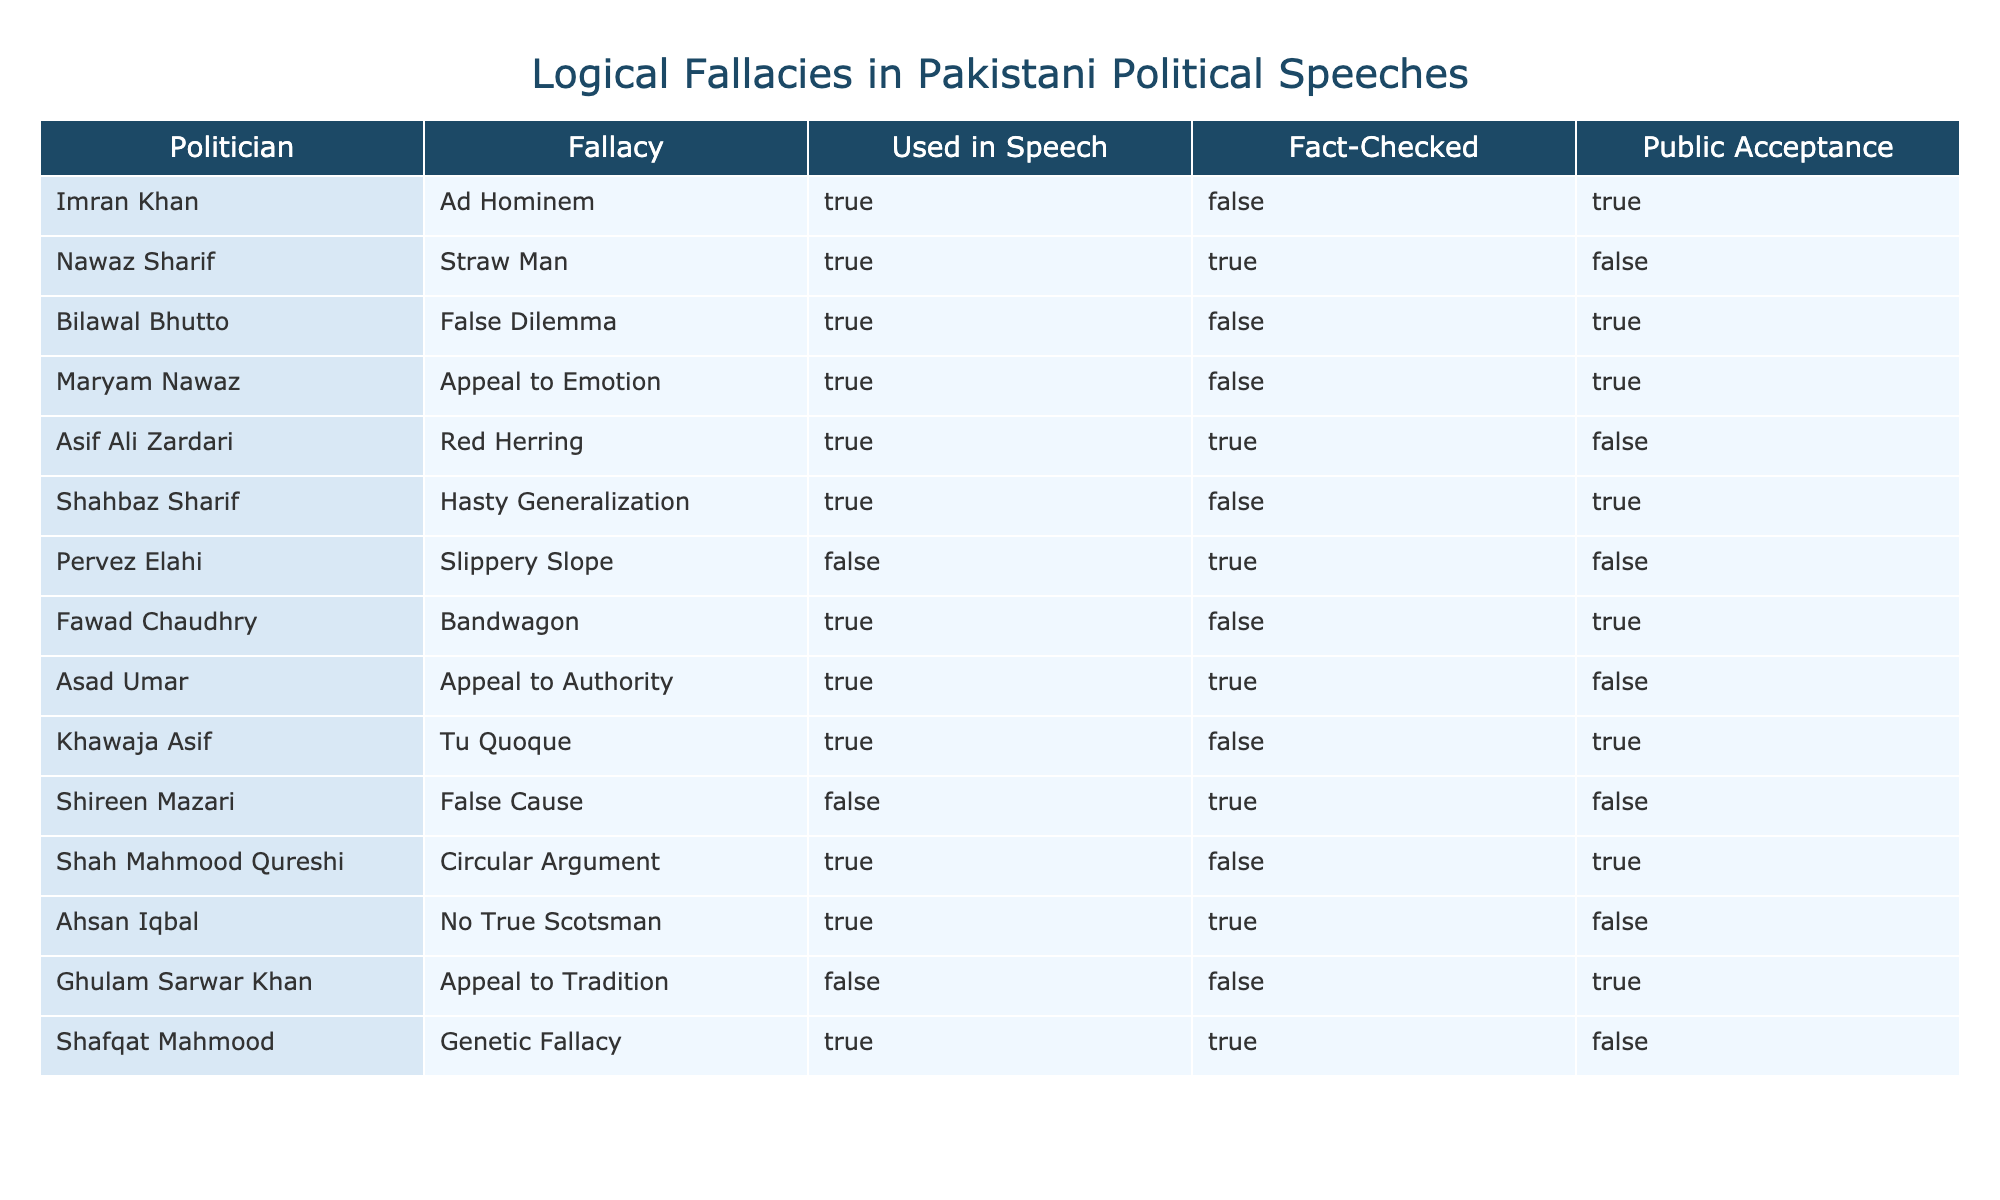What logical fallacy did Bilawal Bhutto use in his speech? According to the table, Bilawal Bhutto used the "False Dilemma" fallacy as indicated in the "Fallacy" column beside his name.
Answer: False Dilemma How many politicians used the Ad Hominem fallacy? The table shows that Imran Khan is the only politician who used the Ad Hominem fallacy. Therefore, there is only one such case.
Answer: 1 What percentage of politicians had their fallacies fact-checked and were still accepted by the public? Among the politicians listed, there are four who had their fallacies fact-checked marked as TRUE and have public acceptance marked as TRUE (Imran Khan, Bilawal Bhutto, Shahbaz Sharif, and Khawaja Asif). Out of 14 politicians, that's approximately 28.6%.
Answer: 28.6% Which politician's fallacy was both fact-checked and accepted by the public? In the table, none of the politicians had their fallacies fact-checked marked as TRUE and also had public acceptance marked as TRUE. Thus, there are no politicians that meet these criteria.
Answer: None What is the total number of politicians who used logical fallacies in their speeches? The table lists 14 politicians, and all of them are associated with a logical fallacy, either TRUE or FALSE in the "Used in Speech" column. Therefore, the total number of politicians using logical fallacies is 14.
Answer: 14 Is the fallacy used by Nawaz Sharif fact-checked? The table indicates that Nawaz Sharif's fallacy, "Straw Man," is marked as TRUE in the "Used in Speech" category but FALSE in the "Fact-Checked" category, meaning it was not fact-checked.
Answer: No How many politicians had their fallacies fact-checked correctly (TRUE) but were still not accepted by the public? From the table, two politicians—Asif Ali Zardari and Ahsan Iqbal—had their fallacies fact-checked marked TRUE and public acceptance marked FALSE, resulting in a total of two politicians.
Answer: 2 Which politician had a fallacy that was neither fact-checked nor used in the speech? The table shows that Ghulam Sarwar Khan had his fallacy marked FALSE in both the "Used in Speech" and "Fact-Checked" columns, indicating it was neither utilized in speech nor fact-checked.
Answer: Ghulam Sarwar Khan What logical fallacy did Shah Mahmood Qureshi use, and was it fact-checked? According to the table, Shah Mahmood Qureshi used the "Circular Argument" fallacy, and his fallacy was marked as FALSE in the "Fact-Checked" column, indicating it was not fact-checked.
Answer: Circular Argument, No 